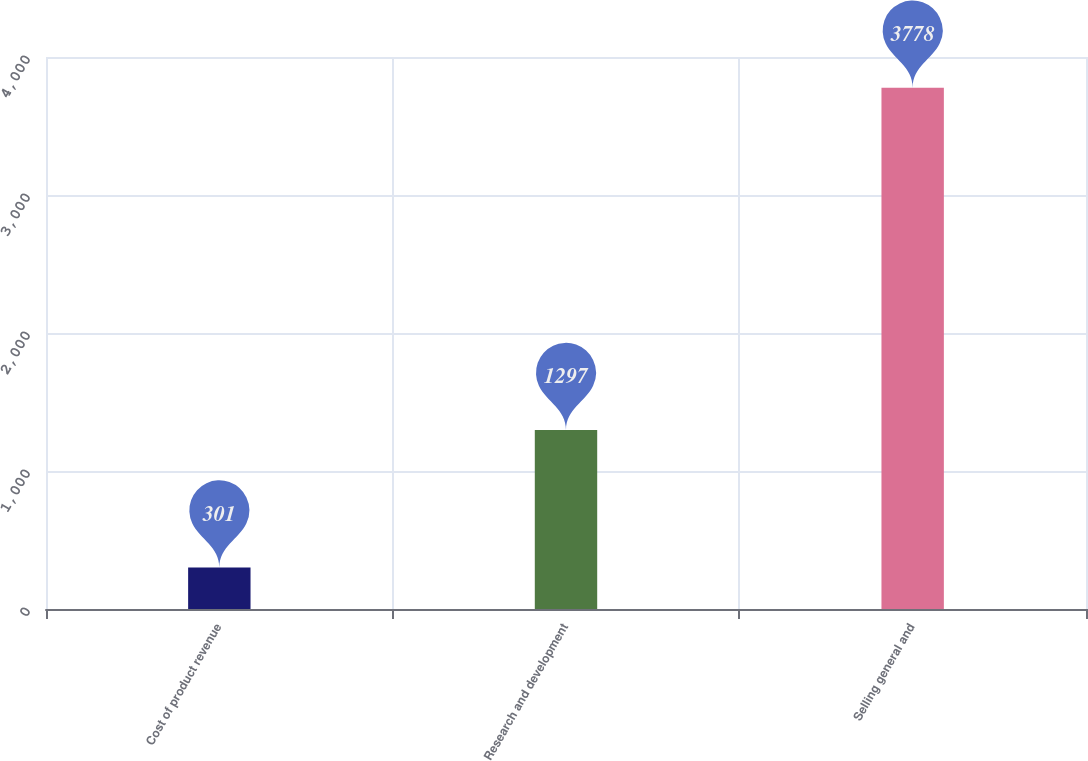Convert chart to OTSL. <chart><loc_0><loc_0><loc_500><loc_500><bar_chart><fcel>Cost of product revenue<fcel>Research and development<fcel>Selling general and<nl><fcel>301<fcel>1297<fcel>3778<nl></chart> 